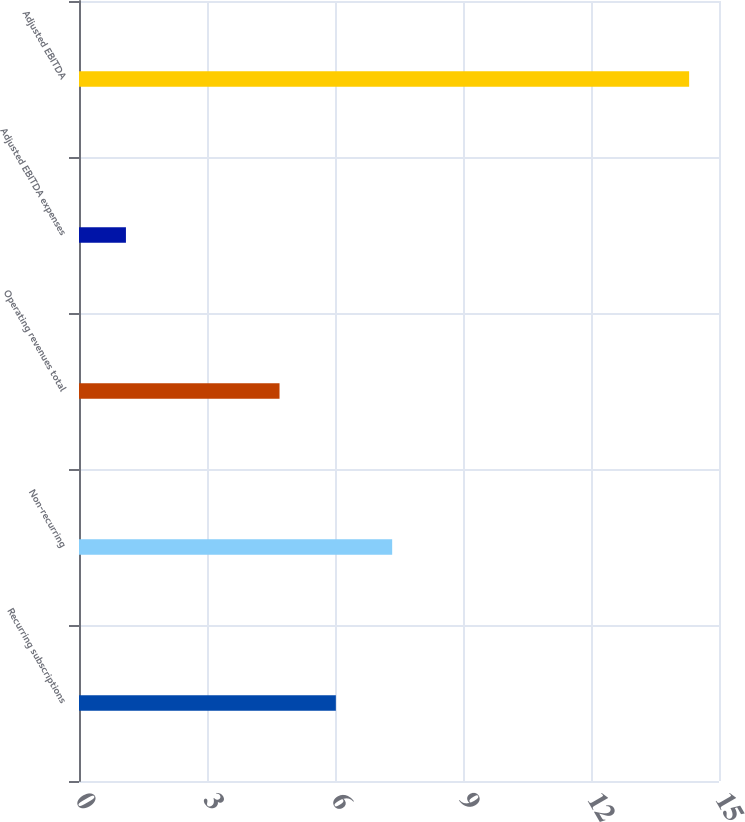Convert chart. <chart><loc_0><loc_0><loc_500><loc_500><bar_chart><fcel>Recurring subscriptions<fcel>Non-recurring<fcel>Operating revenues total<fcel>Adjusted EBITDA expenses<fcel>Adjusted EBITDA<nl><fcel>6.02<fcel>7.34<fcel>4.7<fcel>1.1<fcel>14.3<nl></chart> 